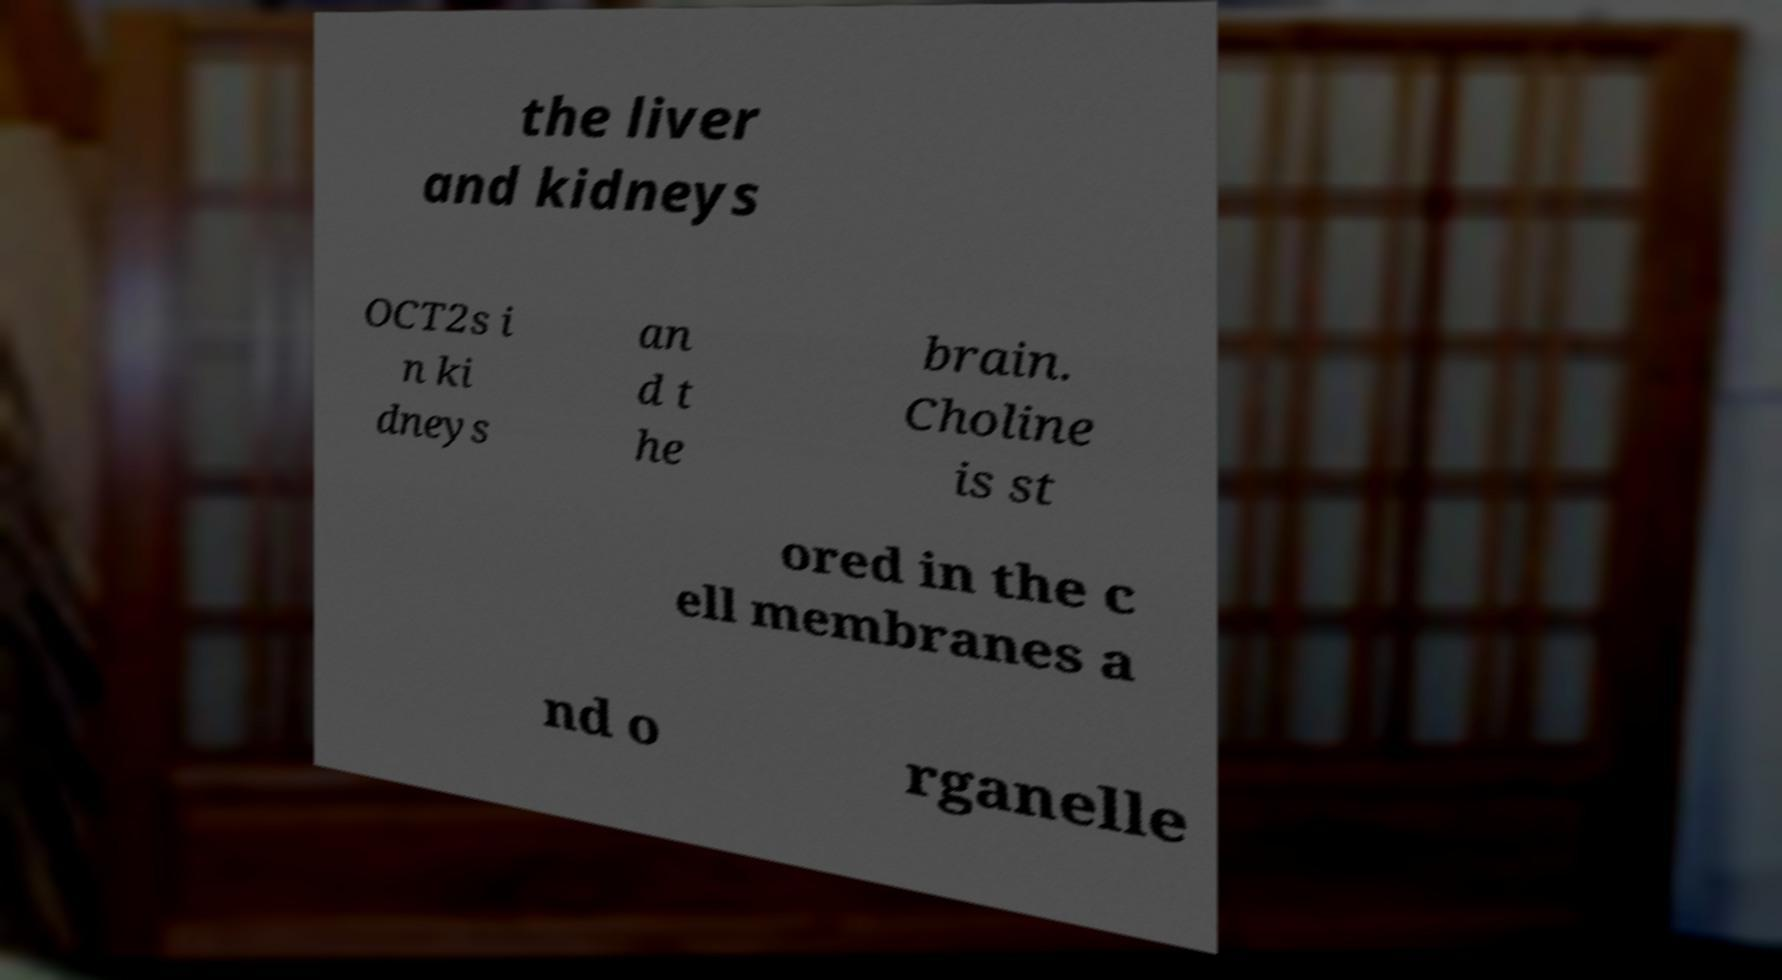Please identify and transcribe the text found in this image. the liver and kidneys OCT2s i n ki dneys an d t he brain. Choline is st ored in the c ell membranes a nd o rganelle 